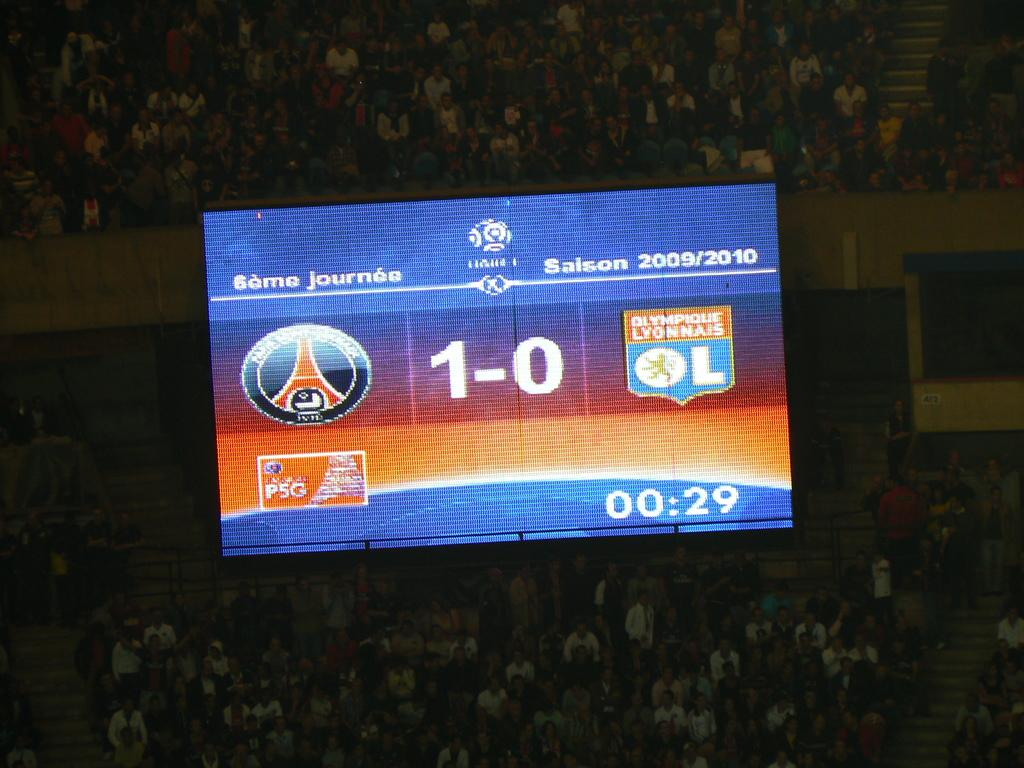<image>
Offer a succinct explanation of the picture presented. A scoreboard is showing the score one to zero on its screen. 